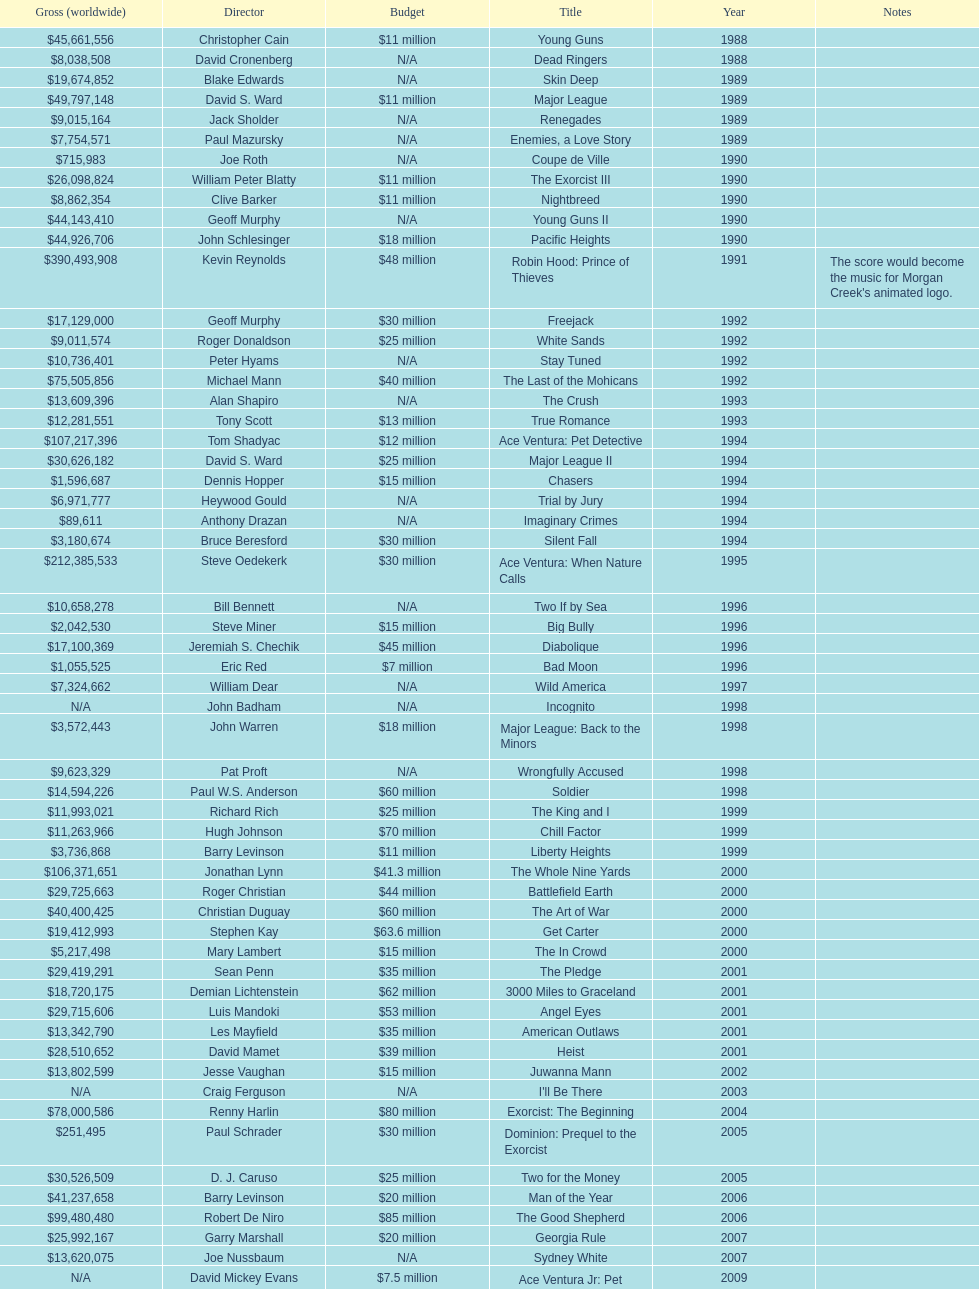Which morgan creek film grossed the most worldwide? Robin Hood: Prince of Thieves. 